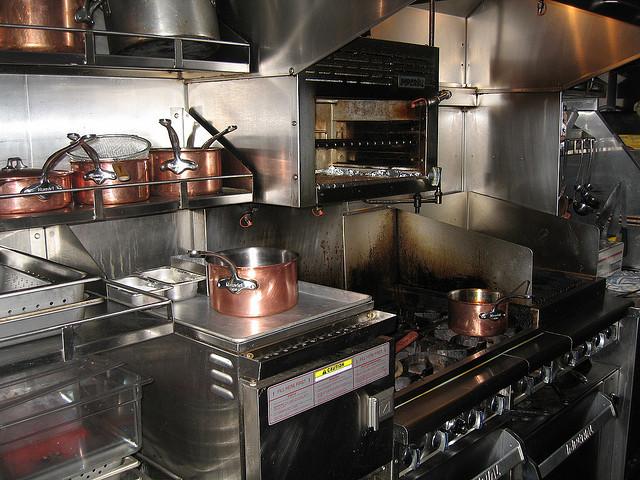Is this in a restaurant or person's home?
Quick response, please. Restaurant. What color are the pots?
Be succinct. Copper. Is this a kitchen restaurant?
Short answer required. Yes. 